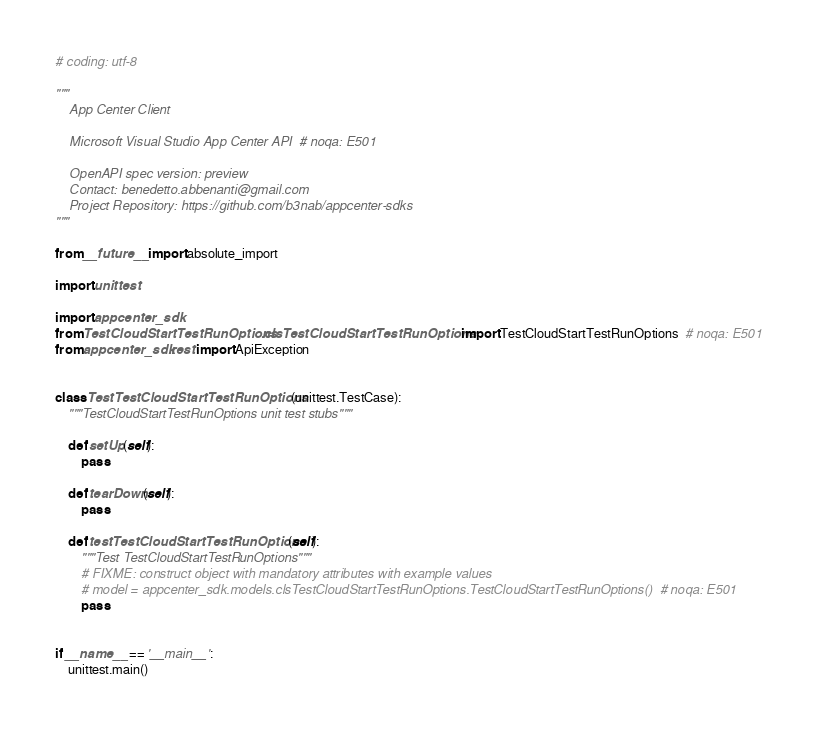<code> <loc_0><loc_0><loc_500><loc_500><_Python_># coding: utf-8

"""
    App Center Client

    Microsoft Visual Studio App Center API  # noqa: E501

    OpenAPI spec version: preview
    Contact: benedetto.abbenanti@gmail.com
    Project Repository: https://github.com/b3nab/appcenter-sdks
"""

from __future__ import absolute_import

import unittest

import appcenter_sdk
from TestCloudStartTestRunOptions.clsTestCloudStartTestRunOptions import TestCloudStartTestRunOptions  # noqa: E501
from appcenter_sdk.rest import ApiException


class TestTestCloudStartTestRunOptions(unittest.TestCase):
    """TestCloudStartTestRunOptions unit test stubs"""

    def setUp(self):
        pass

    def tearDown(self):
        pass

    def testTestCloudStartTestRunOptions(self):
        """Test TestCloudStartTestRunOptions"""
        # FIXME: construct object with mandatory attributes with example values
        # model = appcenter_sdk.models.clsTestCloudStartTestRunOptions.TestCloudStartTestRunOptions()  # noqa: E501
        pass


if __name__ == '__main__':
    unittest.main()
</code> 